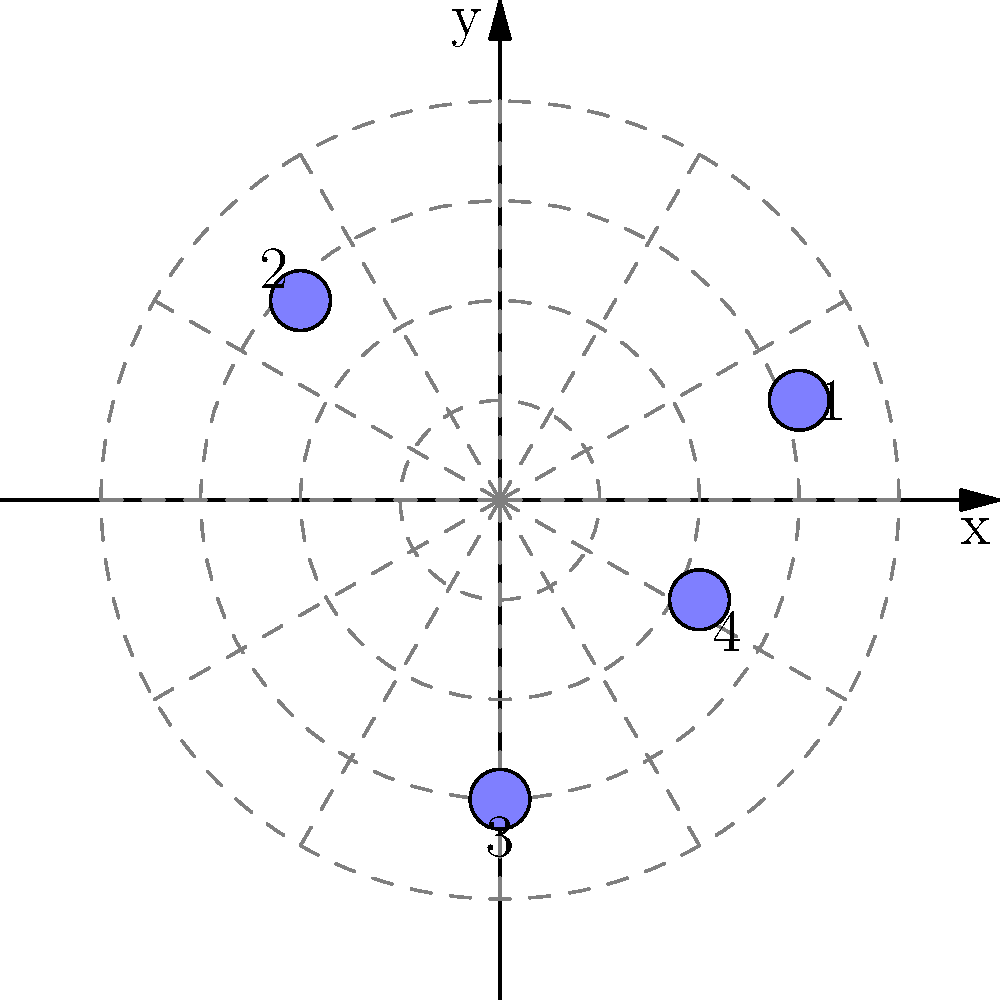A tarot card reader has placed four cards on a table in a specific layout. The positions of the cards are given in Cartesian coordinates as follows: Card 1 (3, 1), Card 2 (-2, 2), Card 3 (0, -3), and Card 4 (2, -1). To add a mystical element to the reading, the reader wants to describe the positions using polar coordinates. What are the polar coordinates $(r, \theta)$ of Card 2, rounded to the nearest whole number for $r$ and the nearest degree for $\theta$? To convert from Cartesian coordinates $(x, y)$ to polar coordinates $(r, \theta)$, we use the following formulas:

1) $r = \sqrt{x^2 + y^2}$
2) $\theta = \tan^{-1}(\frac{y}{x})$

For Card 2, we have $(x, y) = (-2, 2)$

Step 1: Calculate $r$
$r = \sqrt{(-2)^2 + 2^2} = \sqrt{4 + 4} = \sqrt{8} \approx 2.83$
Rounded to the nearest whole number, $r = 3$

Step 2: Calculate $\theta$
$\theta = \tan^{-1}(\frac{2}{-2}) = \tan^{-1}(-1)$

The arctangent of -1 is -45°, but we need to adjust this because we're in the second quadrant (negative x, positive y).

For the second quadrant, we add 180° to the result:
$\theta = -45° + 180° = 135°$

Therefore, the polar coordinates of Card 2 are approximately $(3, 135°)$.
Answer: $(3, 135°)$ 